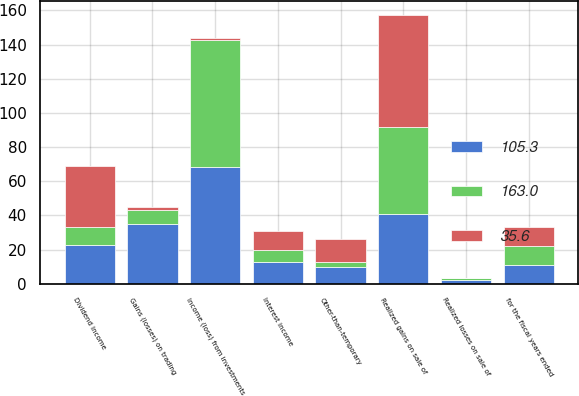<chart> <loc_0><loc_0><loc_500><loc_500><stacked_bar_chart><ecel><fcel>for the fiscal years ended<fcel>Dividend income<fcel>Interest income<fcel>Gains (losses) on trading<fcel>Realized gains on sale of<fcel>Realized losses on sale of<fcel>Income (loss) from investments<fcel>Other-than-temporary<nl><fcel>163<fcel>11<fcel>10.8<fcel>7.5<fcel>8.7<fcel>50.9<fcel>0.9<fcel>74<fcel>2.4<nl><fcel>105.3<fcel>11<fcel>22.5<fcel>12.5<fcel>34.7<fcel>41<fcel>2.2<fcel>68.6<fcel>10.1<nl><fcel>35.6<fcel>11<fcel>35.7<fcel>11<fcel>1.3<fcel>65.5<fcel>0.3<fcel>1.1<fcel>13.6<nl></chart> 